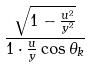<formula> <loc_0><loc_0><loc_500><loc_500>\frac { \sqrt { 1 - \frac { u ^ { 2 } } { y ^ { 2 } } } } { 1 \cdot \frac { u } { y } \cos \theta _ { k } }</formula> 